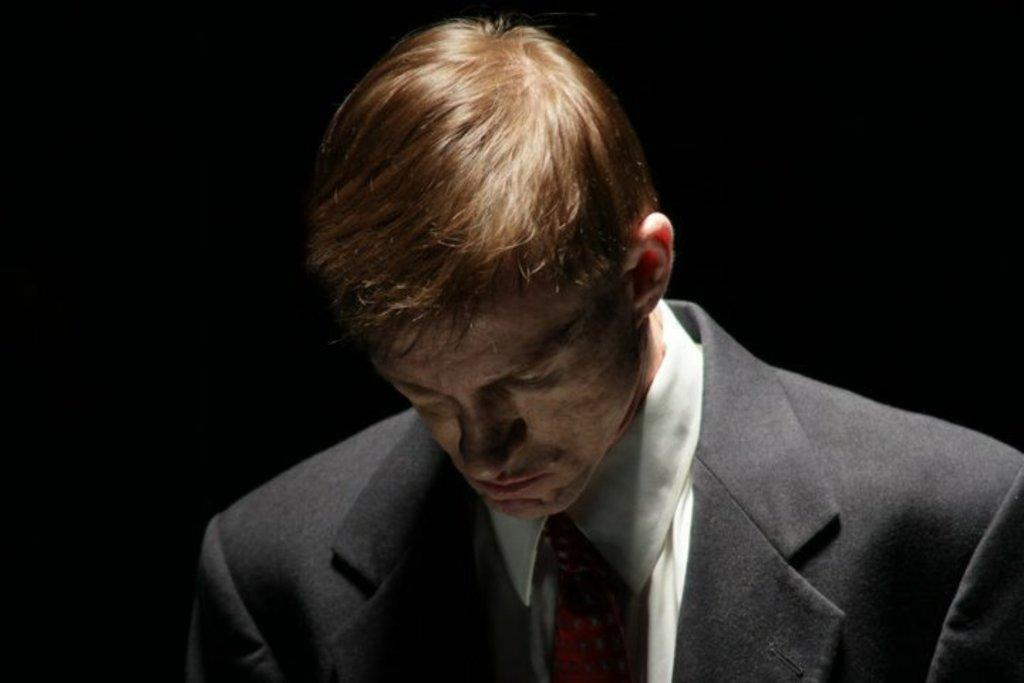What is the main subject of the image? There is a person in the image. How does the person in the image create smoke? There is no indication in the image that the person is creating smoke, as no such activity is depicted. 